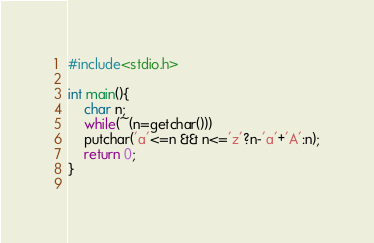Convert code to text. <code><loc_0><loc_0><loc_500><loc_500><_C_>#include<stdio.h>

int main(){
	char n;
	while(~(n=getchar()))
	putchar('a'<=n && n<='z'?n-'a'+'A':n);
	return 0;
}
	</code> 